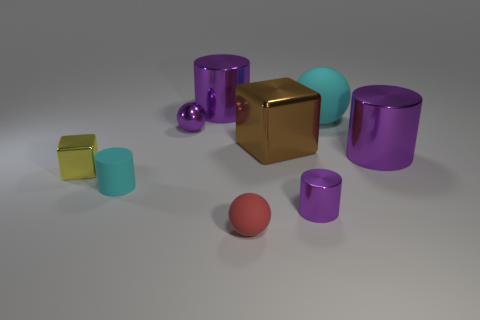Subtract all cyan matte spheres. How many spheres are left? 2 Add 1 matte cylinders. How many objects exist? 10 Subtract all cyan cylinders. How many cylinders are left? 3 Subtract all cylinders. How many objects are left? 5 Subtract 1 spheres. How many spheres are left? 2 Add 6 big shiny things. How many big shiny things are left? 9 Add 1 purple shiny spheres. How many purple shiny spheres exist? 2 Subtract 1 red spheres. How many objects are left? 8 Subtract all yellow balls. Subtract all brown blocks. How many balls are left? 3 Subtract all purple blocks. How many purple cylinders are left? 3 